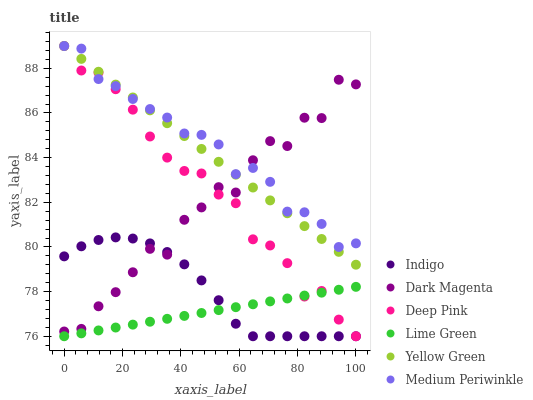Does Lime Green have the minimum area under the curve?
Answer yes or no. Yes. Does Medium Periwinkle have the maximum area under the curve?
Answer yes or no. Yes. Does Indigo have the minimum area under the curve?
Answer yes or no. No. Does Indigo have the maximum area under the curve?
Answer yes or no. No. Is Yellow Green the smoothest?
Answer yes or no. Yes. Is Dark Magenta the roughest?
Answer yes or no. Yes. Is Indigo the smoothest?
Answer yes or no. No. Is Indigo the roughest?
Answer yes or no. No. Does Deep Pink have the lowest value?
Answer yes or no. Yes. Does Dark Magenta have the lowest value?
Answer yes or no. No. Does Yellow Green have the highest value?
Answer yes or no. Yes. Does Indigo have the highest value?
Answer yes or no. No. Is Lime Green less than Medium Periwinkle?
Answer yes or no. Yes. Is Yellow Green greater than Indigo?
Answer yes or no. Yes. Does Indigo intersect Lime Green?
Answer yes or no. Yes. Is Indigo less than Lime Green?
Answer yes or no. No. Is Indigo greater than Lime Green?
Answer yes or no. No. Does Lime Green intersect Medium Periwinkle?
Answer yes or no. No. 